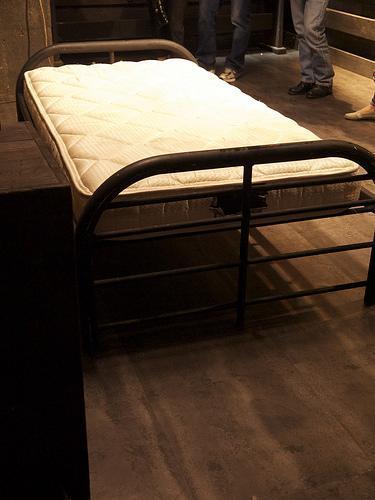How many beds are there?
Give a very brief answer. 1. 